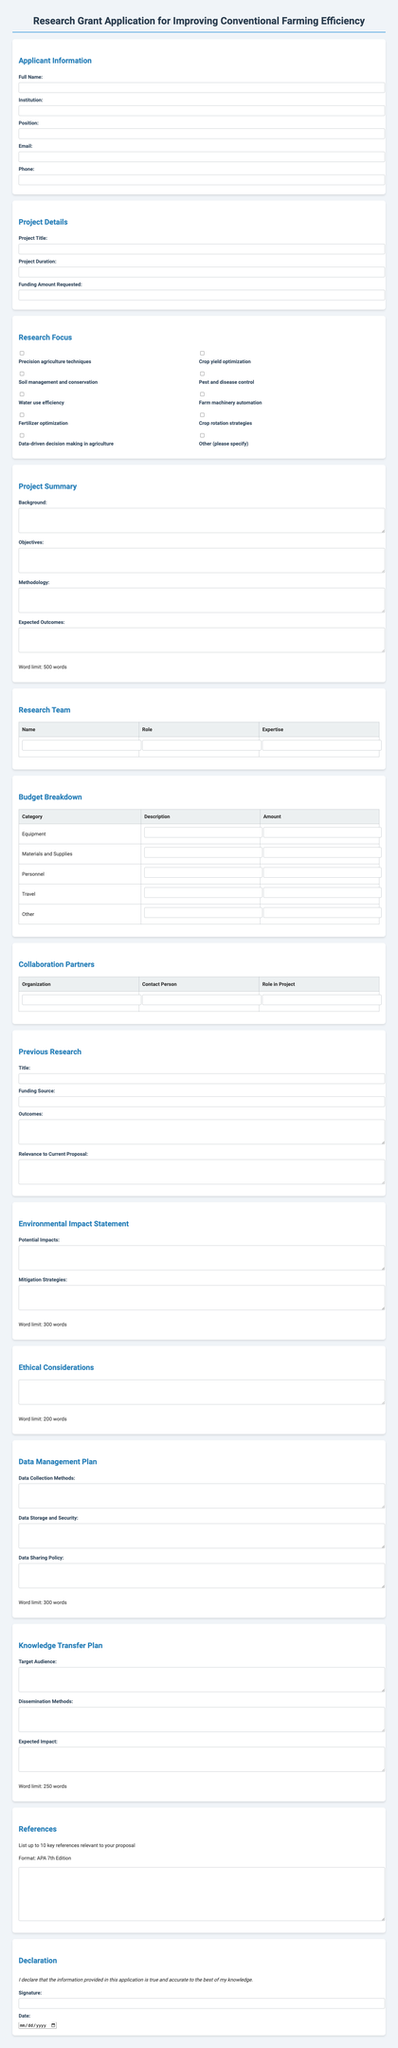what is the project title? The project title is a field that needs to be filled out by the applicant in the project details section.
Answer: [Project Title] what is the funding amount requested? This is the amount that the applicant is seeking for their project detailed in the project details section.
Answer: [Funding Amount Requested] list two research focuses mentioned in the document. The research focuses are options provided in the form that applicants can choose from.
Answer: Precision agriculture techniques, Crop yield optimization how many words are allowed in the project summary? The word limit for the project summary is specified in the document to guide applicants on the length of their responses.
Answer: 500 which section requires the declaration statement? The declaration section is where the applicant confirms that the information provided is true and accurate.
Answer: Declaration what are the potential impacts mentioned in the environmental impact statement? The potential impacts section requires the applicant to describe any possible impacts their project might have.
Answer: [Potential Impacts] who is the contact person for collaboration partners? The contact person is a required entry for each collaboration partner listed in the respective section.
Answer: [Contact Person] what is the word limit for ethical considerations? The word limit for ethical considerations is specified in order to help the applicant provide concise information.
Answer: 200 how many key references can be listed? There is a specific limit set for the number of key references that can be included in the document.
Answer: 10 